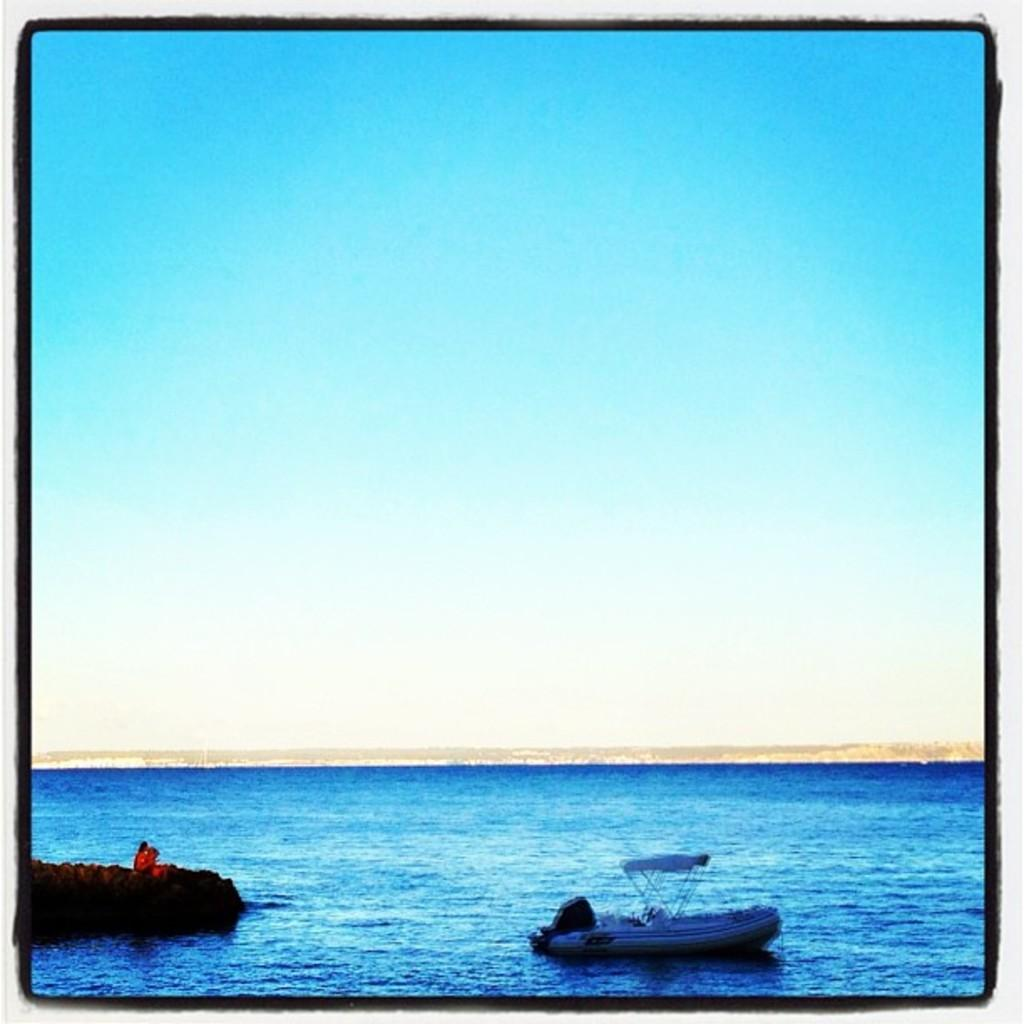What is located at the bottom of the image? A: There are boats in the water at the bottom of the image. What can be seen at the top of the image? The sky is blue and visible at the top of the image. Can you describe the setting of the image? The image may have been taken in the ocean, given the presence of boats in the water. How many ants can be seen crawling on the boats in the image? There are no ants present in the image; it features boats in the water. What direction does the crook take in the image? There is no crook or any indication of a person taking a specific direction in the image. 